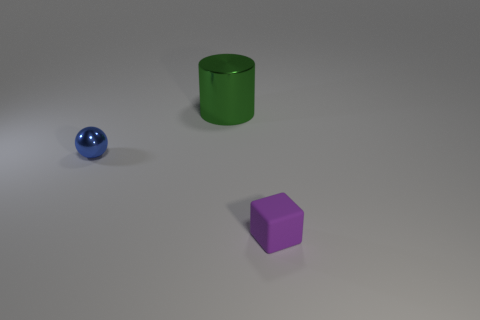Is there any other thing that has the same material as the small block?
Give a very brief answer. No. There is a object that is both in front of the big metallic cylinder and behind the tiny purple rubber object; what is its shape?
Your answer should be compact. Sphere. Is there another yellow metal thing of the same shape as the tiny metal thing?
Give a very brief answer. No. There is a thing that is left of the green cylinder; is it the same size as the cylinder behind the small blue metallic thing?
Provide a short and direct response. No. Is the number of tiny blue balls greater than the number of large yellow things?
Provide a short and direct response. Yes. How many small purple blocks have the same material as the big green object?
Make the answer very short. 0. How big is the thing that is behind the small thing left of the small thing that is to the right of the green metal thing?
Keep it short and to the point. Large. Is there a purple block that is left of the green thing behind the small metallic thing?
Give a very brief answer. No. There is a tiny thing in front of the tiny thing left of the large metallic cylinder; what number of green cylinders are to the left of it?
Offer a terse response. 1. There is a object that is both in front of the metal cylinder and to the right of the tiny blue thing; what is its color?
Your response must be concise. Purple. 